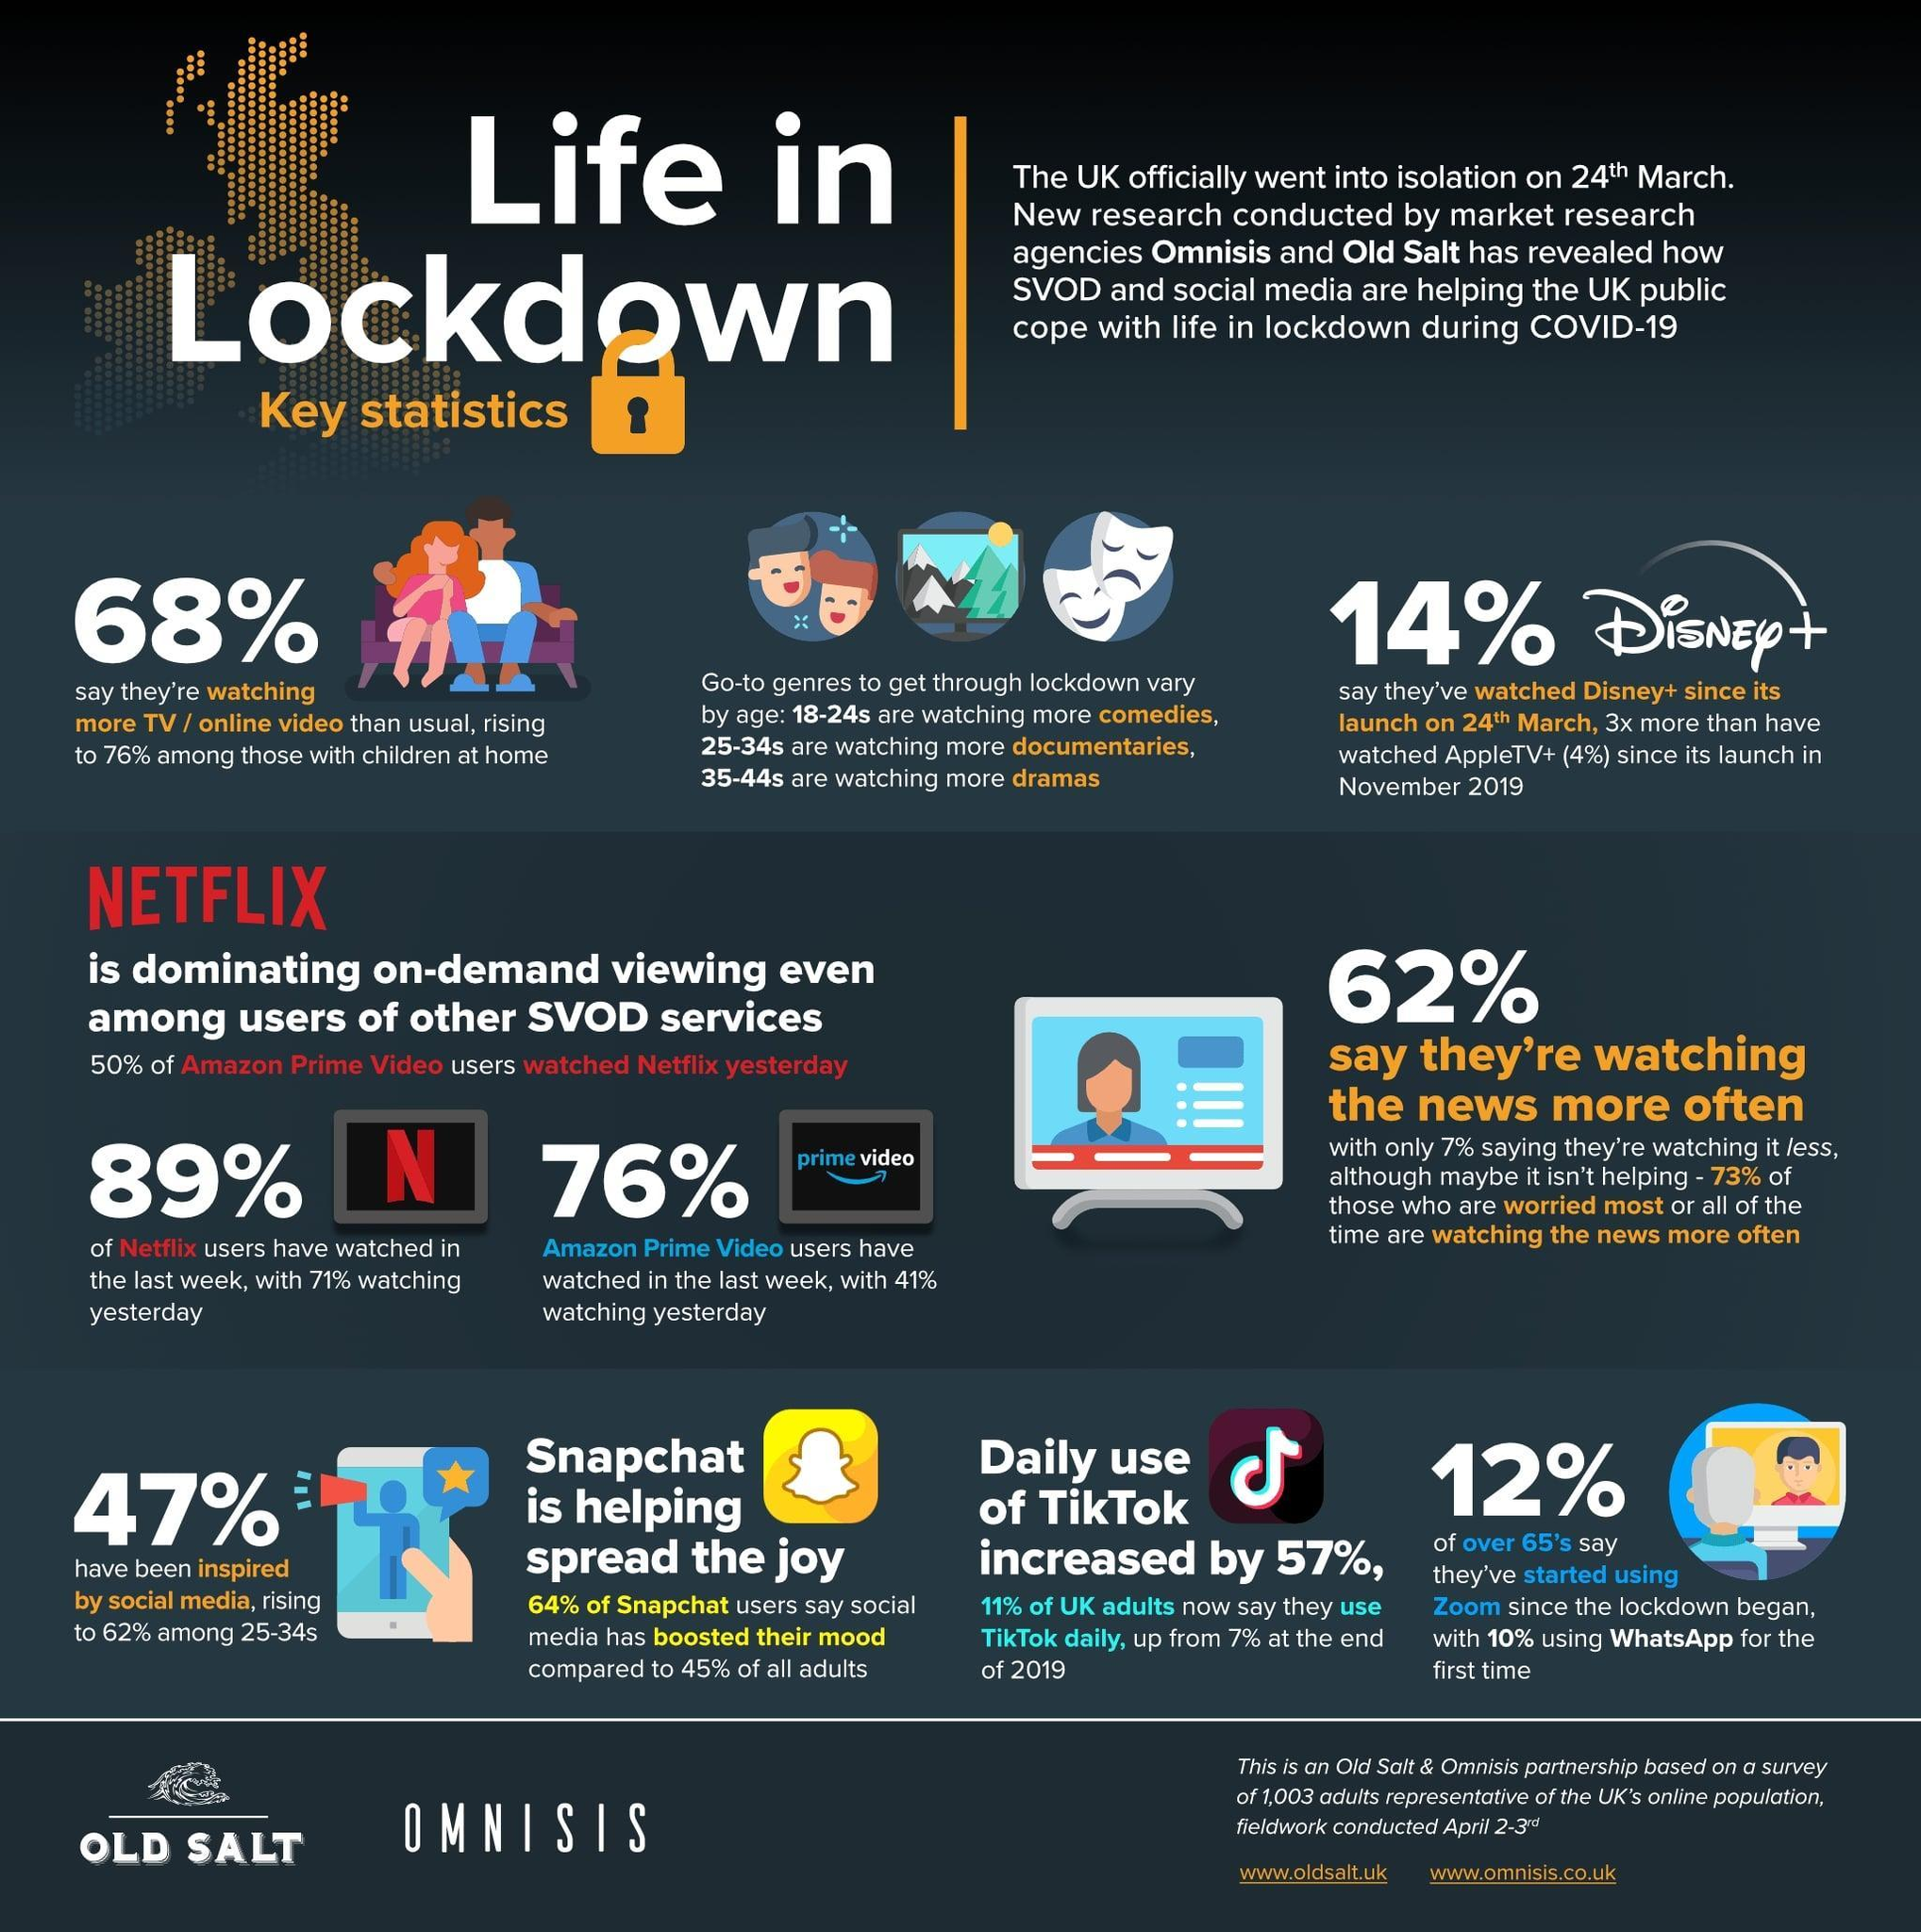how many are watching news more often
Answer the question with a short phrase. 62% what has been the increase in TikTok from 2019 7% what has been the increase in viewership of Disney when compared to AppleTV 3x what percentage of senior citizens have started using zoom 12% 